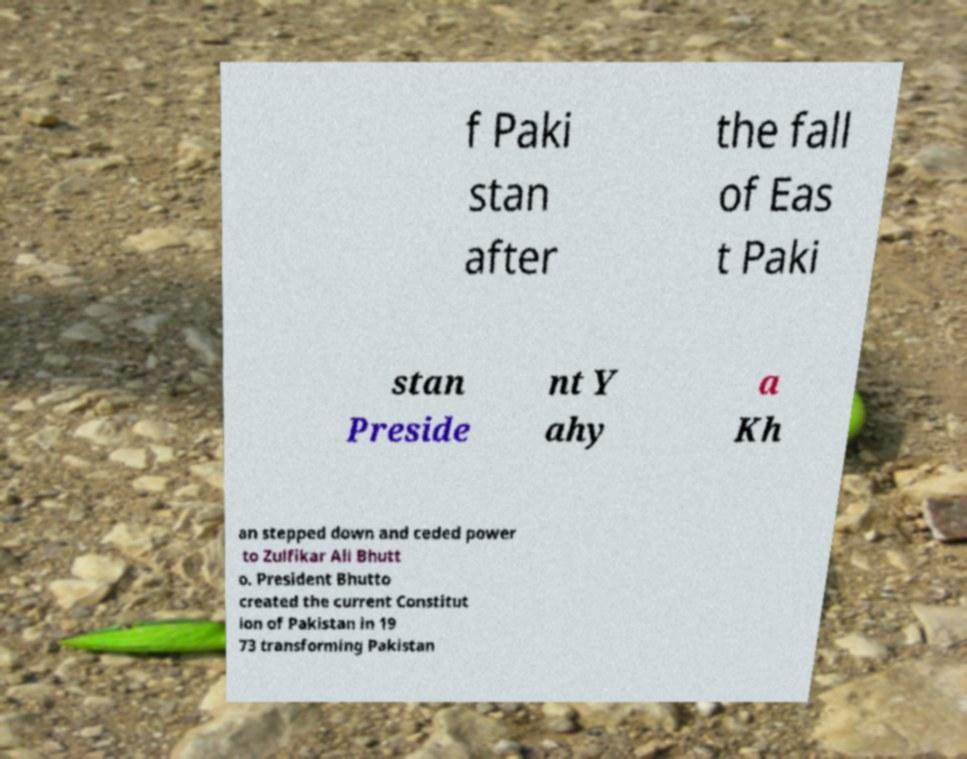Could you assist in decoding the text presented in this image and type it out clearly? f Paki stan after the fall of Eas t Paki stan Preside nt Y ahy a Kh an stepped down and ceded power to Zulfikar Ali Bhutt o. President Bhutto created the current Constitut ion of Pakistan in 19 73 transforming Pakistan 